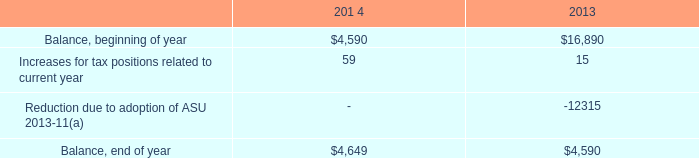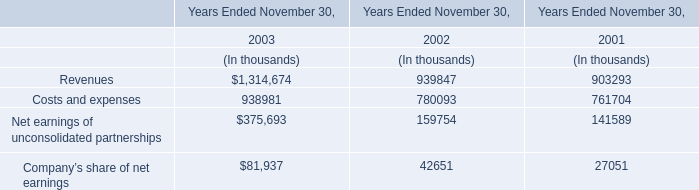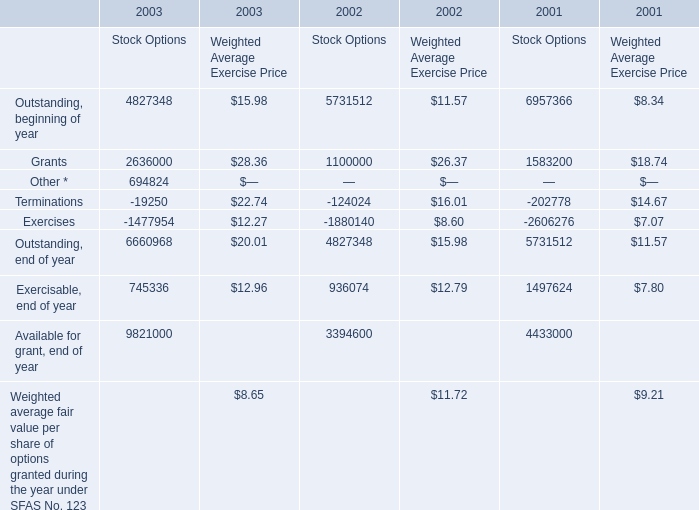What's the sum of Grants of 2002 Stock Options, and Balance, end of year of 201 4 ? 
Computations: (1100000.0 + 4649.0)
Answer: 1104649.0. 